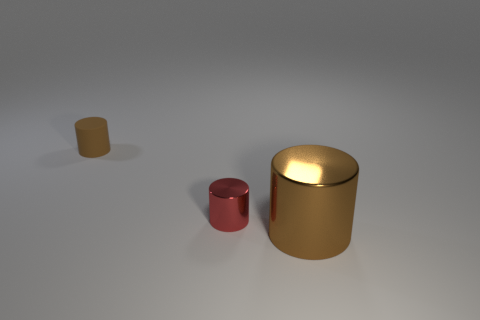Add 3 cyan balls. How many objects exist? 6 Add 2 big metallic cylinders. How many big metallic cylinders exist? 3 Subtract 0 brown balls. How many objects are left? 3 Subtract all red cylinders. Subtract all yellow rubber blocks. How many objects are left? 2 Add 1 metallic cylinders. How many metallic cylinders are left? 3 